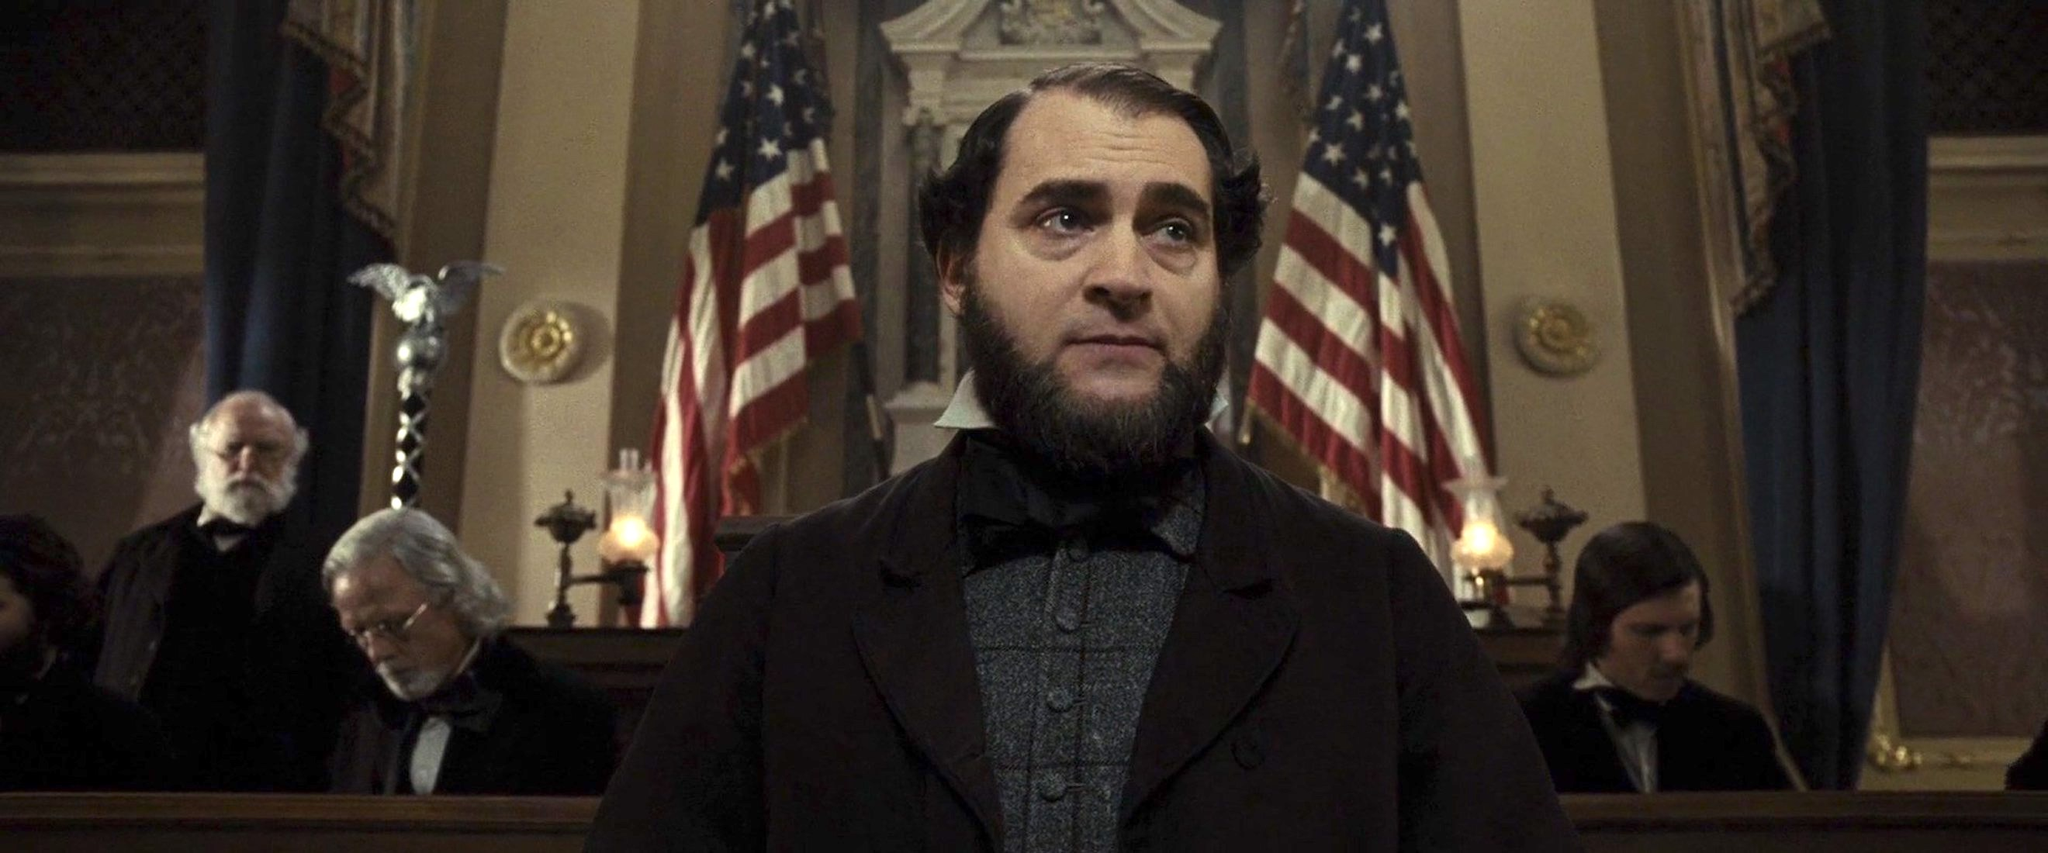Explain the significance of the main character's attire. The main character's attire is highly significant, as it reflects the fashion and societal norms of a specific historical period. Dressed in a black suit with a formal shirt and a meticulously groomed beard, he presents a dignified and authoritative figure. Such attire was typical for gentlemen in the 19th century, particularly those in positions of power or influence, such as lawyers, politicians, or other public figures. This choice of clothing helps to convey the character's social status and the serious nature of the proceedings he is involved in. What does the presence of the American flags behind him symbolize? The American flags behind the main character symbolize patriotism and the authority of the government or judicial system. Their prominent display in the scene underscores the setting's official and ceremonial nature, suggesting that the proceedings are of significant national importance. The flags serve to remind viewers of the principles of liberty, justice, and unity that the nation stands for, reinforcing the gravity and dignity of the historical moment being depicted. Is there any significance to the positioning of other individuals in the background? The positioning of other individuals in the background adds depth to the scene, highlighting its complexity and the multitude of perspectives present. The blurred faces suggest they are witnesses, jury members, or other figures involved in the proceedings, providing a sense of the event's communal importance. Their relatively subdued presence ensures that the focus remains on the central figure, but their inclusion indicates the broader impact of the moment being captured, resonating with various societal segments connected to the historical event. What if the courtroom was part of a science fiction story? How would you describe the scene then? In a science fiction story, this courtroom could be transformed into a futuristic tribunal where laws of interstellar justice are upheld. The central figure might be an ambassador from Earth, standing at a sleek, holographic podium, dressed in a blend of traditional formal wear and high-tech elements. The American flags could be replaced with futuristic insignias or flags representing a united intergalactic federation. The background could feature alien species and advanced AI entities observing the proceedings, their presence blurred not by camera focus, but by a deliberate cloaking technology to signify security protocols. The solemn expressions would still exist, but now they signify deliberation on matters that could affect entire planets or star systems. The setting would be a harmonious blend of classical courtroom architecture with cutting-edge technology, symbolizing the timeless nature of justice transcending even the boundaries of space and time. 